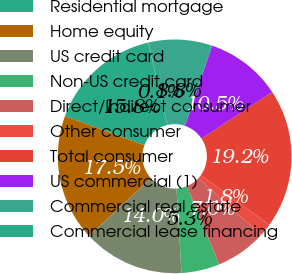Convert chart. <chart><loc_0><loc_0><loc_500><loc_500><pie_chart><fcel>Residential mortgage<fcel>Home equity<fcel>US credit card<fcel>Non-US credit card<fcel>Direct/Indirect consumer<fcel>Other consumer<fcel>Total consumer<fcel>US commercial (1)<fcel>Commercial real estate<fcel>Commercial lease financing<nl><fcel>15.76%<fcel>17.51%<fcel>14.02%<fcel>5.29%<fcel>7.03%<fcel>1.79%<fcel>19.25%<fcel>10.52%<fcel>8.78%<fcel>0.05%<nl></chart> 